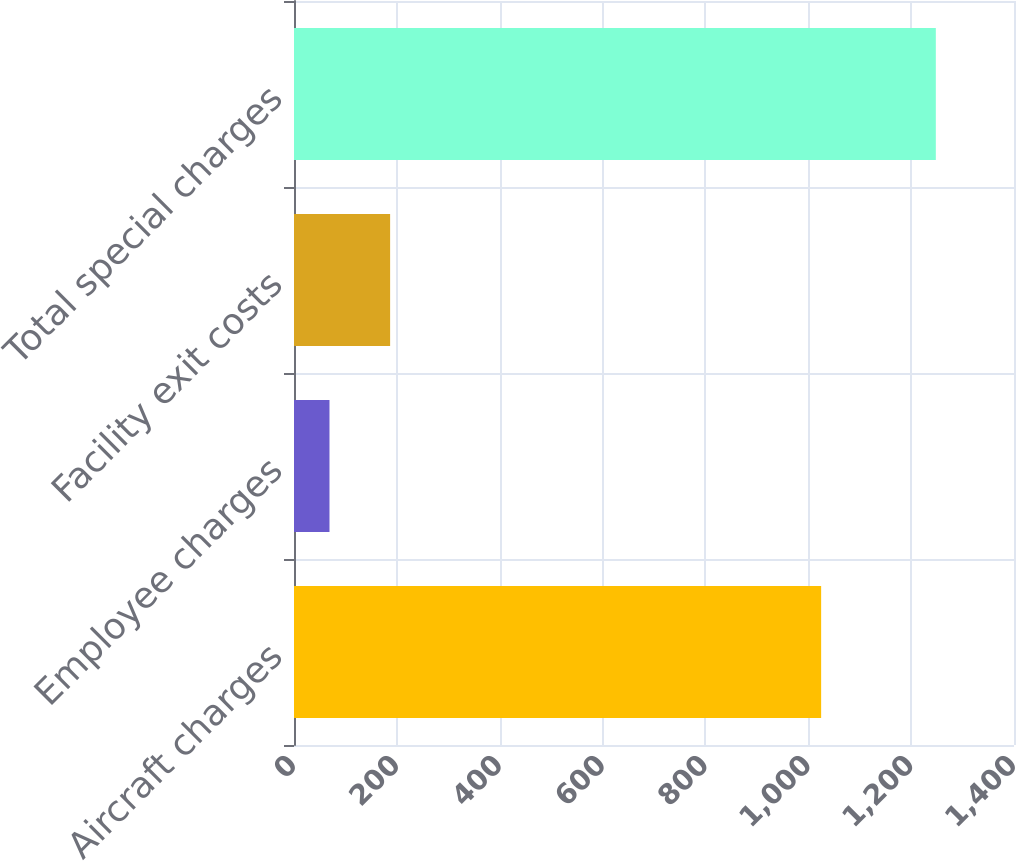<chart> <loc_0><loc_0><loc_500><loc_500><bar_chart><fcel>Aircraft charges<fcel>Employee charges<fcel>Facility exit costs<fcel>Total special charges<nl><fcel>1025<fcel>69<fcel>186.9<fcel>1248<nl></chart> 